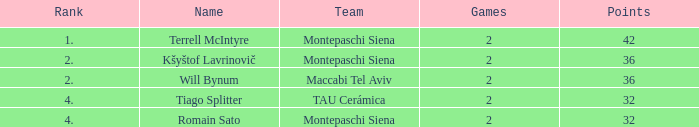What is the highest game that has 32 points and a team rank larger than 4 named montepaschi siena None. 